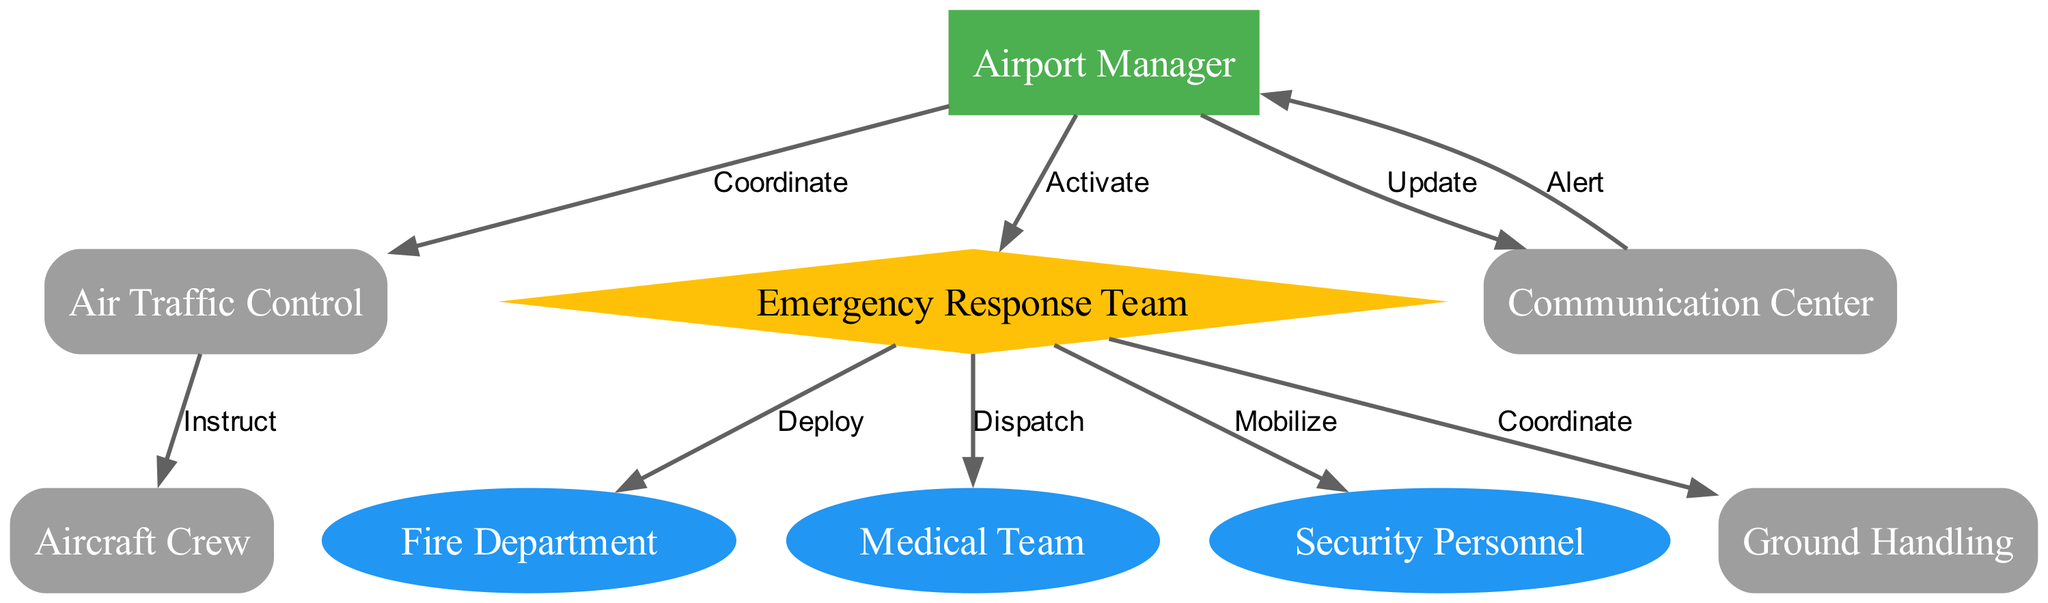What is the first step in the emergency response procedure? The emergency response procedure begins with the Communication Center alerting the Airport Manager.
Answer: Alert How many edges are there in the diagram? The diagram contains 9 edges that represent the relationships between different nodes in the emergency response process.
Answer: 9 Who coordinates with the Air Traffic Control? The Airport Manager is responsible for coordinating with the Air Traffic Control as part of the emergency response procedure.
Answer: Airport Manager What action does the Emergency Response Team take towards the Fire Department? The Emergency Response Team deploys the Fire Department as part of the response actions outlined in the diagram.
Answer: Deploy Which node has the most connections in the diagram? The Emergency Response Team has the most connections, linking to the Fire Department, Medical Team, Security Personnel, and Ground Handling.
Answer: Emergency Response Team What does the Emergency Response Team do after being activated by the Airport Manager? After being activated by the Airport Manager, the Emergency Response Team dispatches the Medical Team as part of their emergency actions.
Answer: Dispatch What is the shape of the Airport Manager node? The Airport Manager node is represented in a box shape, highlighting its significance within the emergency response hierarchy.
Answer: Box How does the Communication Center provide updates? The Airport Manager updates the Communication Center after coordinating actions with other teams and entities in the emergency response process.
Answer: Update What is the role of Air Traffic Control in this scenario? Air Traffic Control is instructed by the Airport Manager to manage aircraft movements during the emergency situation.
Answer: Instruct 